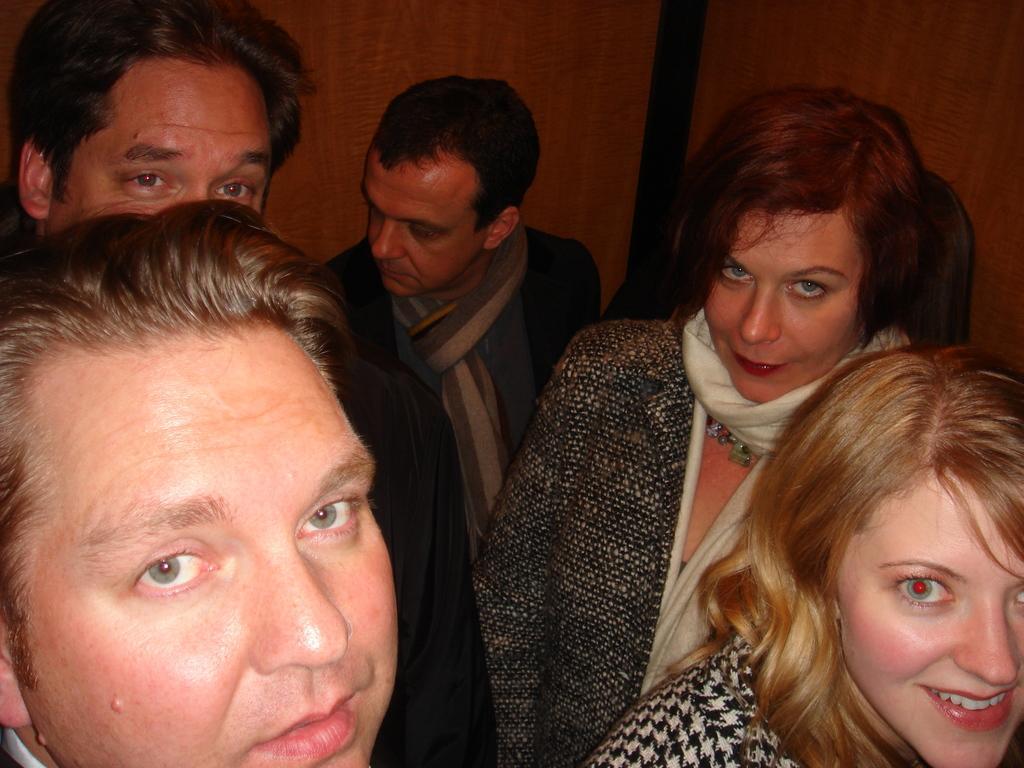Could you give a brief overview of what you see in this image? In this image there are a few people standing. In the background there is a wall. 